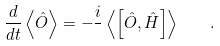Convert formula to latex. <formula><loc_0><loc_0><loc_500><loc_500>\frac { d } { d t } \left \langle \hat { O } \right \rangle = - \frac { i } { } \left \langle \left [ \hat { O } , \hat { H } \right ] \right \rangle \quad .</formula> 